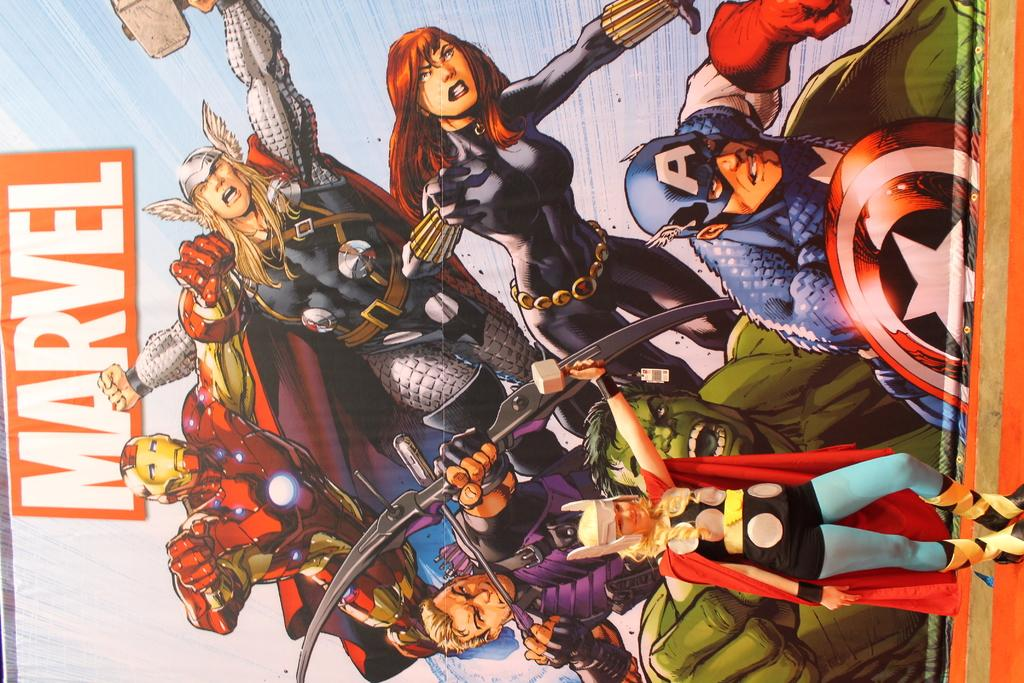What is the main object in the image? There is a board in the image. What is happening on the board? There is a group of people on the board. What can be seen on the board itself? Something is written on the board. What is the person in front of the board wearing? There is a person with a costume in front of the board. Where is the train station located in the image? There is no train station present in the image. What type of pleasure can be experienced by the people on the board? The provided facts do not mention any specific pleasure being experienced by the people on the board. 